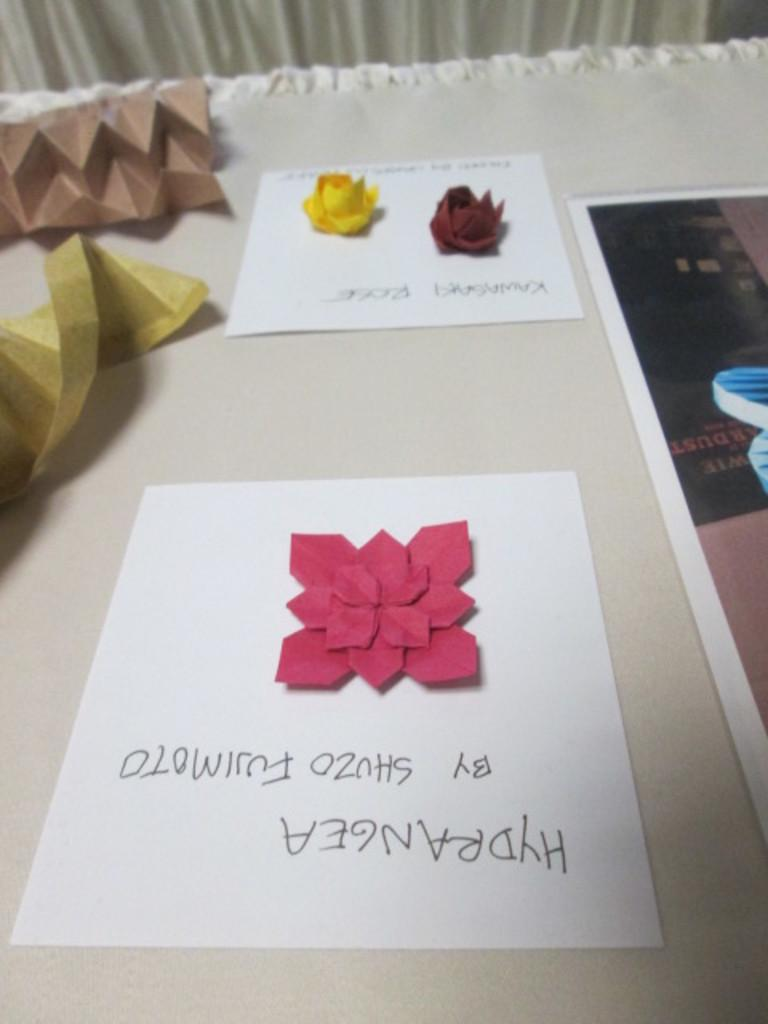What is the primary color of the surface in the image? The surface in the image is white. What can be seen on the white surface? There are crafts visible on the white surface. Can you describe anything in the background of the image? A part of the curtain is visible in the background of the image. How many shoes are placed on the white surface in the image? There are no shoes present on the white surface in the image. Can you describe the owl sitting on the crafts in the image? There is no owl present in the image; it only features crafts on a white surface and a part of the curtain in the background. 